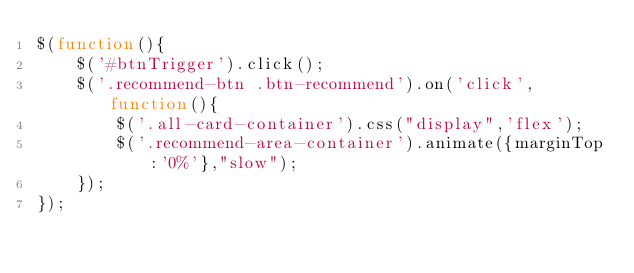<code> <loc_0><loc_0><loc_500><loc_500><_JavaScript_>$(function(){
    $('#btnTrigger').click();
    $('.recommend-btn .btn-recommend').on('click',function(){
        $('.all-card-container').css("display",'flex');
        $('.recommend-area-container').animate({marginTop:'0%'},"slow"); 
    });
});
</code> 